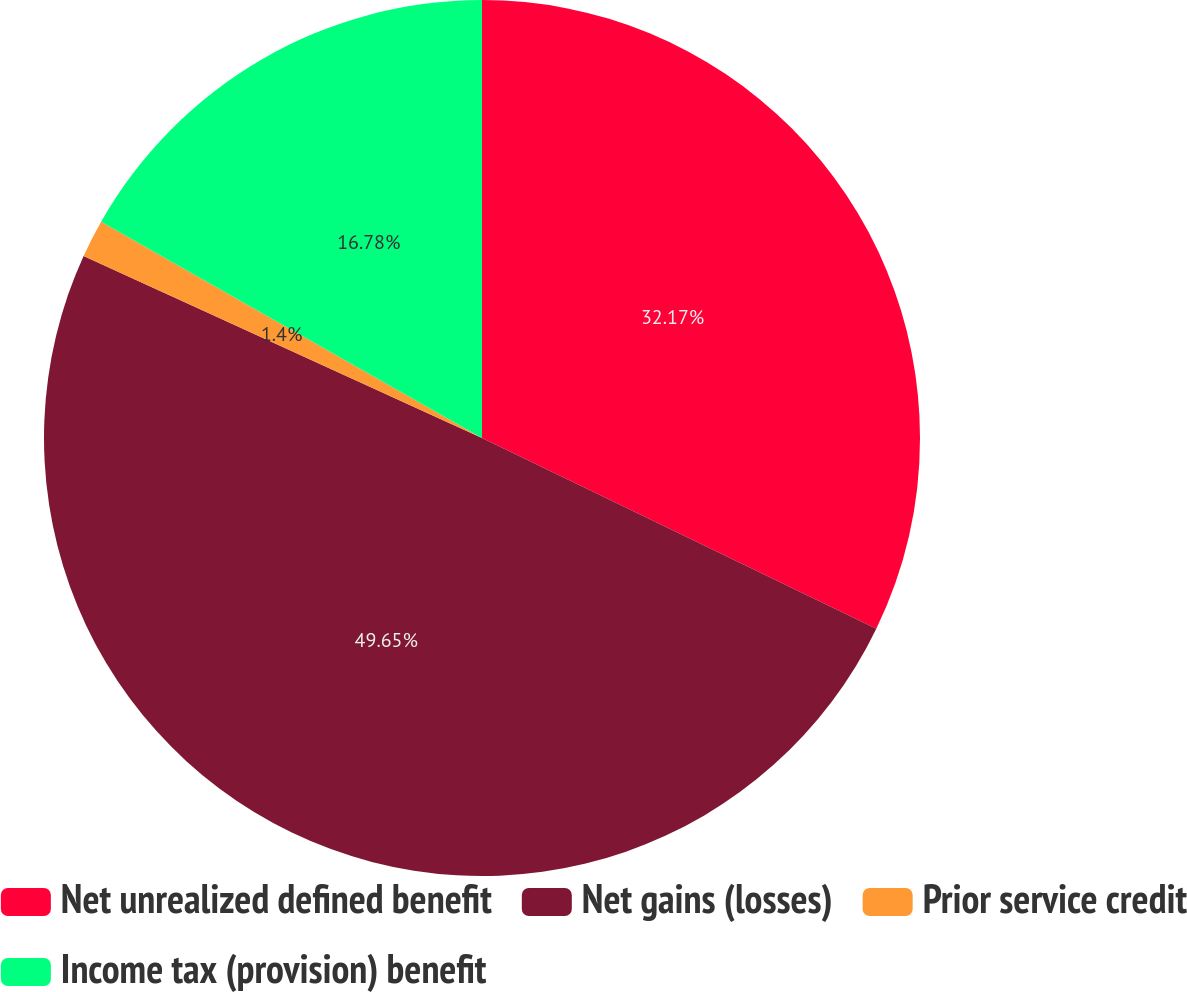Convert chart to OTSL. <chart><loc_0><loc_0><loc_500><loc_500><pie_chart><fcel>Net unrealized defined benefit<fcel>Net gains (losses)<fcel>Prior service credit<fcel>Income tax (provision) benefit<nl><fcel>32.17%<fcel>49.65%<fcel>1.4%<fcel>16.78%<nl></chart> 